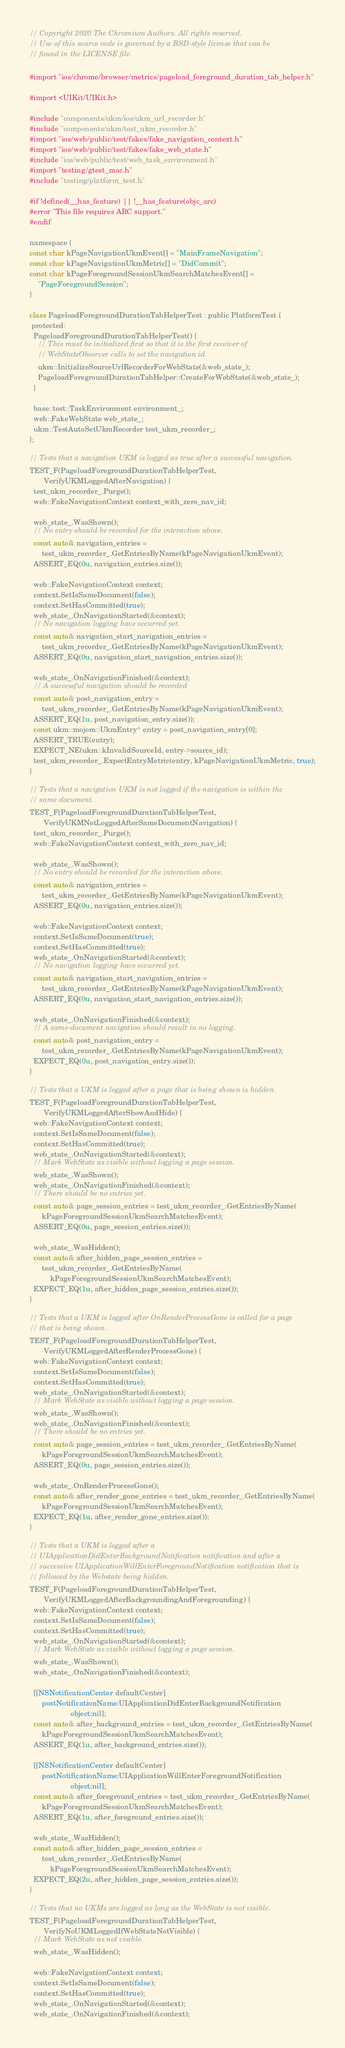<code> <loc_0><loc_0><loc_500><loc_500><_ObjectiveC_>// Copyright 2020 The Chromium Authors. All rights reserved.
// Use of this source code is governed by a BSD-style license that can be
// found in the LICENSE file.

#import "ios/chrome/browser/metrics/pageload_foreground_duration_tab_helper.h"

#import <UIKit/UIKit.h>

#include "components/ukm/ios/ukm_url_recorder.h"
#include "components/ukm/test_ukm_recorder.h"
#import "ios/web/public/test/fakes/fake_navigation_context.h"
#import "ios/web/public/test/fakes/fake_web_state.h"
#include "ios/web/public/test/web_task_environment.h"
#import "testing/gtest_mac.h"
#include "testing/platform_test.h"

#if !defined(__has_feature) || !__has_feature(objc_arc)
#error "This file requires ARC support."
#endif

namespace {
const char kPageNavigationUkmEvent[] = "MainFrameNavigation";
const char kPageNavigationUkmMetric[] = "DidCommit";
const char kPageForegroundSessionUkmSearchMatchesEvent[] =
    "PageForegroundSession";
}

class PageloadForegroundDurationTabHelperTest : public PlatformTest {
 protected:
  PageloadForegroundDurationTabHelperTest() {
    // This must be initialized first so that it is the first receiver of
    // WebStateObserver calls to set the navigation id.
    ukm::InitializeSourceUrlRecorderForWebState(&web_state_);
    PageloadForegroundDurationTabHelper::CreateForWebState(&web_state_);
  }

  base::test::TaskEnvironment environment_;
  web::FakeWebState web_state_;
  ukm::TestAutoSetUkmRecorder test_ukm_recorder_;
};

// Tests that a navigation UKM is logged as true after a successful navigation.
TEST_F(PageloadForegroundDurationTabHelperTest,
       VerifyUKMLoggedAfterNavigation) {
  test_ukm_recorder_.Purge();
  web::FakeNavigationContext context_with_zero_nav_id;

  web_state_.WasShown();
  // No entry should be recorded for the interaction above.
  const auto& navigation_entries =
      test_ukm_recorder_.GetEntriesByName(kPageNavigationUkmEvent);
  ASSERT_EQ(0u, navigation_entries.size());

  web::FakeNavigationContext context;
  context.SetIsSameDocument(false);
  context.SetHasCommitted(true);
  web_state_.OnNavigationStarted(&context);
  // No navigation logging have occurred yet.
  const auto& navigation_start_navigation_entries =
      test_ukm_recorder_.GetEntriesByName(kPageNavigationUkmEvent);
  ASSERT_EQ(0u, navigation_start_navigation_entries.size());

  web_state_.OnNavigationFinished(&context);
  // A successful navigation should be recorded
  const auto& post_navigation_entry =
      test_ukm_recorder_.GetEntriesByName(kPageNavigationUkmEvent);
  ASSERT_EQ(1u, post_navigation_entry.size());
  const ukm::mojom::UkmEntry* entry = post_navigation_entry[0];
  ASSERT_TRUE(entry);
  EXPECT_NE(ukm::kInvalidSourceId, entry->source_id);
  test_ukm_recorder_.ExpectEntryMetric(entry, kPageNavigationUkmMetric, true);
}

// Tests that a navigation UKM is not logged if the navigation is within the
// same document.
TEST_F(PageloadForegroundDurationTabHelperTest,
       VerifyUKMNotLoggedAfterSameDocumentNavigation) {
  test_ukm_recorder_.Purge();
  web::FakeNavigationContext context_with_zero_nav_id;

  web_state_.WasShown();
  // No entry should be recorded for the interaction above.
  const auto& navigation_entries =
      test_ukm_recorder_.GetEntriesByName(kPageNavigationUkmEvent);
  ASSERT_EQ(0u, navigation_entries.size());

  web::FakeNavigationContext context;
  context.SetIsSameDocument(true);
  context.SetHasCommitted(true);
  web_state_.OnNavigationStarted(&context);
  // No navigation logging have occurred yet.
  const auto& navigation_start_navigation_entries =
      test_ukm_recorder_.GetEntriesByName(kPageNavigationUkmEvent);
  ASSERT_EQ(0u, navigation_start_navigation_entries.size());

  web_state_.OnNavigationFinished(&context);
  // A same-document navigation should result in no logging.
  const auto& post_navigation_entry =
      test_ukm_recorder_.GetEntriesByName(kPageNavigationUkmEvent);
  EXPECT_EQ(0u, post_navigation_entry.size());
}

// Tests that a UKM is logged after a page that is being shown is hidden.
TEST_F(PageloadForegroundDurationTabHelperTest,
       VerifyUKMLoggedAfterShowAndHide) {
  web::FakeNavigationContext context;
  context.SetIsSameDocument(false);
  context.SetHasCommitted(true);
  web_state_.OnNavigationStarted(&context);
  // Mark WebState as visible without logging a page session.
  web_state_.WasShown();
  web_state_.OnNavigationFinished(&context);
  // There should be no entries yet.
  const auto& page_session_entries = test_ukm_recorder_.GetEntriesByName(
      kPageForegroundSessionUkmSearchMatchesEvent);
  ASSERT_EQ(0u, page_session_entries.size());

  web_state_.WasHidden();
  const auto& after_hidden_page_session_entries =
      test_ukm_recorder_.GetEntriesByName(
          kPageForegroundSessionUkmSearchMatchesEvent);
  EXPECT_EQ(1u, after_hidden_page_session_entries.size());
}

// Tests that a UKM is logged after OnRenderProcessGone is called for a page
// that is being shown.
TEST_F(PageloadForegroundDurationTabHelperTest,
       VerifyUKMLoggedAfterRenderProcessGone) {
  web::FakeNavigationContext context;
  context.SetIsSameDocument(false);
  context.SetHasCommitted(true);
  web_state_.OnNavigationStarted(&context);
  // Mark WebState as visible without logging a page session.
  web_state_.WasShown();
  web_state_.OnNavigationFinished(&context);
  // There should be no entries yet.
  const auto& page_session_entries = test_ukm_recorder_.GetEntriesByName(
      kPageForegroundSessionUkmSearchMatchesEvent);
  ASSERT_EQ(0u, page_session_entries.size());

  web_state_.OnRenderProcessGone();
  const auto& after_render_gone_entries = test_ukm_recorder_.GetEntriesByName(
      kPageForegroundSessionUkmSearchMatchesEvent);
  EXPECT_EQ(1u, after_render_gone_entries.size());
}

// Tests that a UKM is logged after a
// UIApplicationDidEnterBackgroundNotification notification and after a
// successive UIApplicationWillEnterForegroundNotification notification that is
// followed by the Webstate being hidden.
TEST_F(PageloadForegroundDurationTabHelperTest,
       VerifyUKMLoggedAfterBackgroundingAndForegrounding) {
  web::FakeNavigationContext context;
  context.SetIsSameDocument(false);
  context.SetHasCommitted(true);
  web_state_.OnNavigationStarted(&context);
  // Mark WebState as visible without logging a page session.
  web_state_.WasShown();
  web_state_.OnNavigationFinished(&context);

  [[NSNotificationCenter defaultCenter]
      postNotificationName:UIApplicationDidEnterBackgroundNotification
                    object:nil];
  const auto& after_background_entries = test_ukm_recorder_.GetEntriesByName(
      kPageForegroundSessionUkmSearchMatchesEvent);
  ASSERT_EQ(1u, after_background_entries.size());

  [[NSNotificationCenter defaultCenter]
      postNotificationName:UIApplicationWillEnterForegroundNotification
                    object:nil];
  const auto& after_foreground_entries = test_ukm_recorder_.GetEntriesByName(
      kPageForegroundSessionUkmSearchMatchesEvent);
  ASSERT_EQ(1u, after_foreground_entries.size());

  web_state_.WasHidden();
  const auto& after_hidden_page_session_entries =
      test_ukm_recorder_.GetEntriesByName(
          kPageForegroundSessionUkmSearchMatchesEvent);
  EXPECT_EQ(2u, after_hidden_page_session_entries.size());
}

// Tests that no UKMs are logged as long as the WebState is not visible.
TEST_F(PageloadForegroundDurationTabHelperTest,
       VerifyNoUKMLoggedIfWebStateNotVisible) {
  // Mark WebState as not visible.
  web_state_.WasHidden();

  web::FakeNavigationContext context;
  context.SetIsSameDocument(false);
  context.SetHasCommitted(true);
  web_state_.OnNavigationStarted(&context);
  web_state_.OnNavigationFinished(&context);</code> 